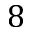<formula> <loc_0><loc_0><loc_500><loc_500>8</formula> 